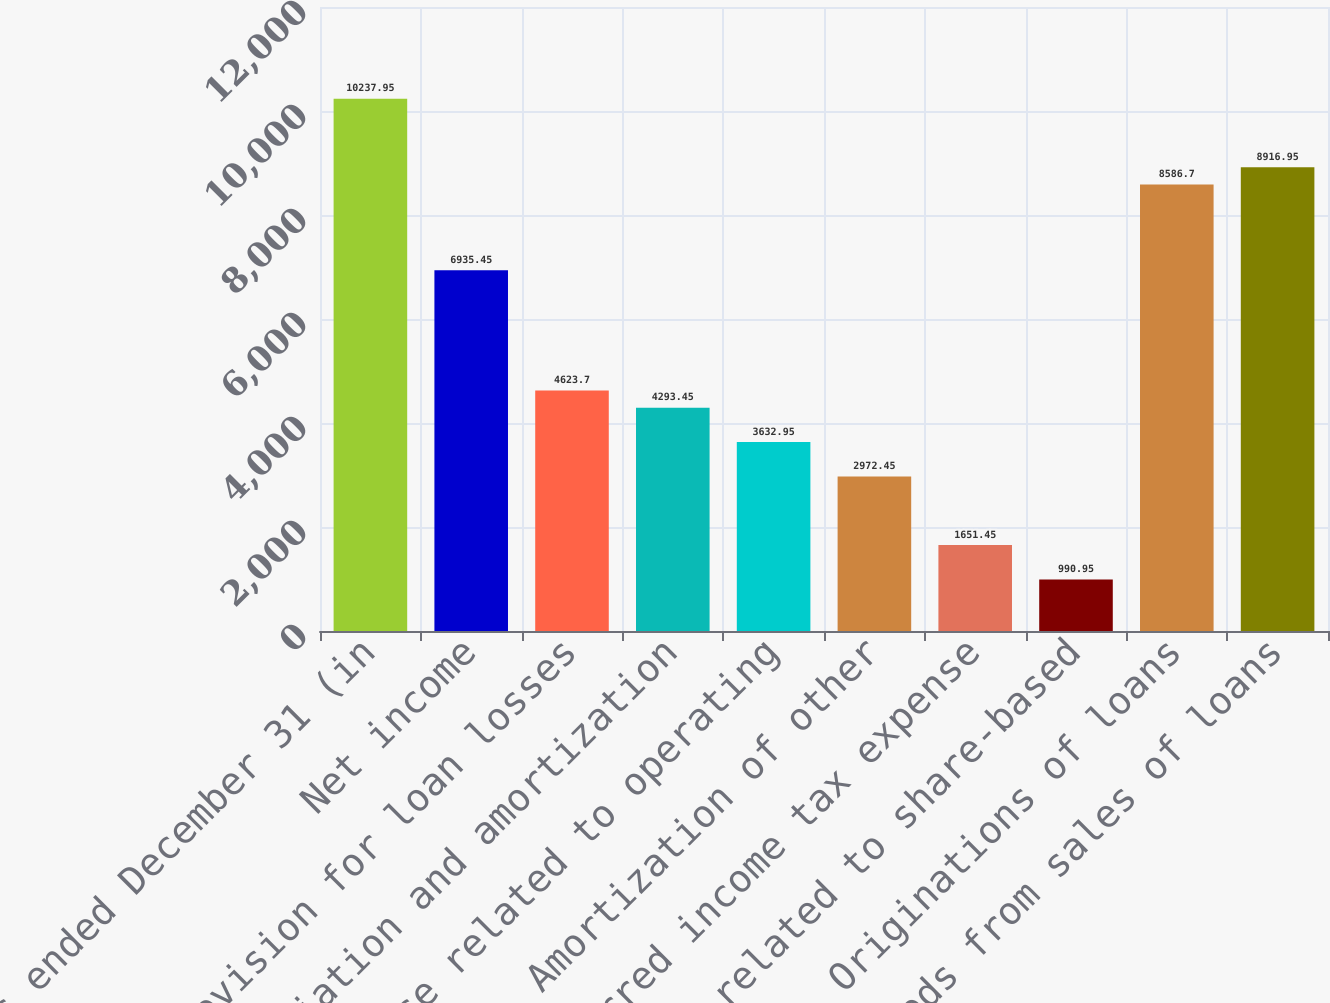<chart> <loc_0><loc_0><loc_500><loc_500><bar_chart><fcel>Years ended December 31 (in<fcel>Net income<fcel>Provision for loan losses<fcel>Depreciation and amortization<fcel>Expense related to operating<fcel>Amortization of other<fcel>Deferred income tax expense<fcel>Expense related to share-based<fcel>Originations of loans<fcel>Proceeds from sales of loans<nl><fcel>10238<fcel>6935.45<fcel>4623.7<fcel>4293.45<fcel>3632.95<fcel>2972.45<fcel>1651.45<fcel>990.95<fcel>8586.7<fcel>8916.95<nl></chart> 